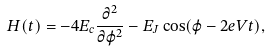Convert formula to latex. <formula><loc_0><loc_0><loc_500><loc_500>H ( t ) = - 4 E _ { c } \frac { \partial ^ { 2 } } { \partial \varphi ^ { 2 } } - E _ { J } \cos ( \varphi - 2 e V t ) ,</formula> 